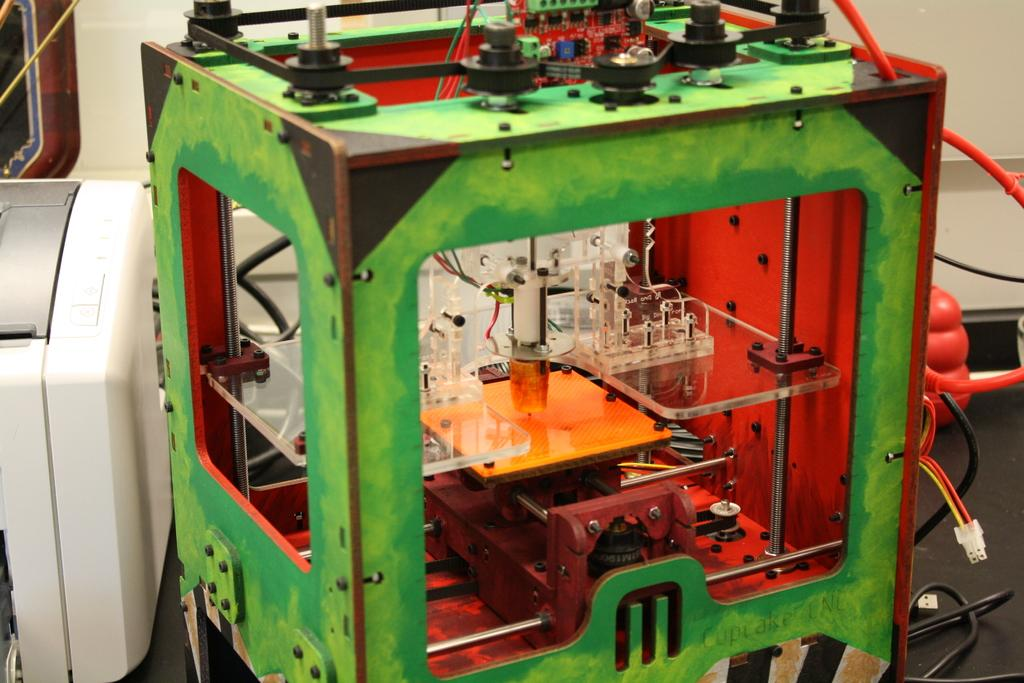What is the main subject in the center of the image? There is an electronic device in the center of the image. What can be seen in the background of the image? There is a white color wall in the background of the image. Are there any other devices visible in the image? Yes, there is another device to the left side of the image. How does the hope for a rainstorm affect the electronic devices in the image? There is no mention of hope or a rainstorm in the image, so it cannot be determined how they might affect the electronic devices. 